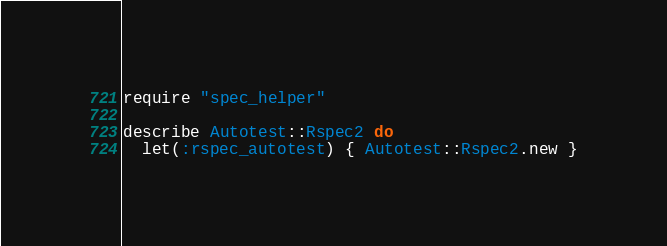<code> <loc_0><loc_0><loc_500><loc_500><_Ruby_>require "spec_helper"

describe Autotest::Rspec2 do
  let(:rspec_autotest) { Autotest::Rspec2.new }</code> 